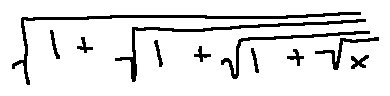<formula> <loc_0><loc_0><loc_500><loc_500>\sqrt { 1 + \sqrt { 1 + \sqrt { 1 + \sqrt { x } } } }</formula> 